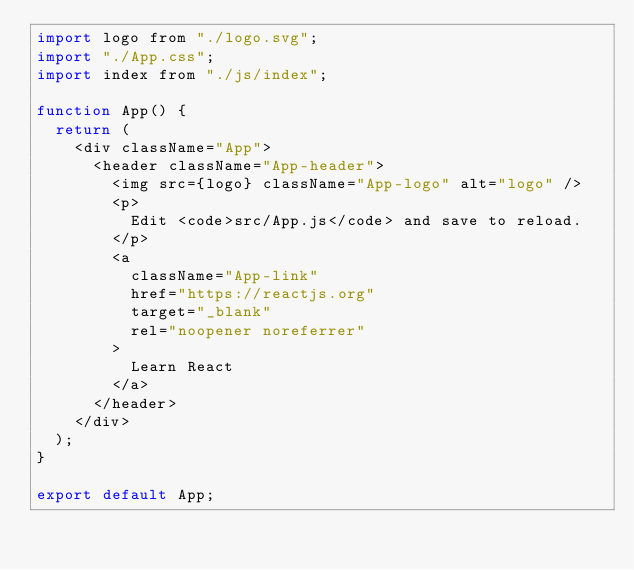<code> <loc_0><loc_0><loc_500><loc_500><_JavaScript_>import logo from "./logo.svg";
import "./App.css";
import index from "./js/index";

function App() {
  return (
    <div className="App">
      <header className="App-header">
        <img src={logo} className="App-logo" alt="logo" />
        <p>
          Edit <code>src/App.js</code> and save to reload.
        </p>
        <a
          className="App-link"
          href="https://reactjs.org"
          target="_blank"
          rel="noopener noreferrer"
        >
          Learn React
        </a>
      </header>
    </div>
  );
}

export default App;
</code> 